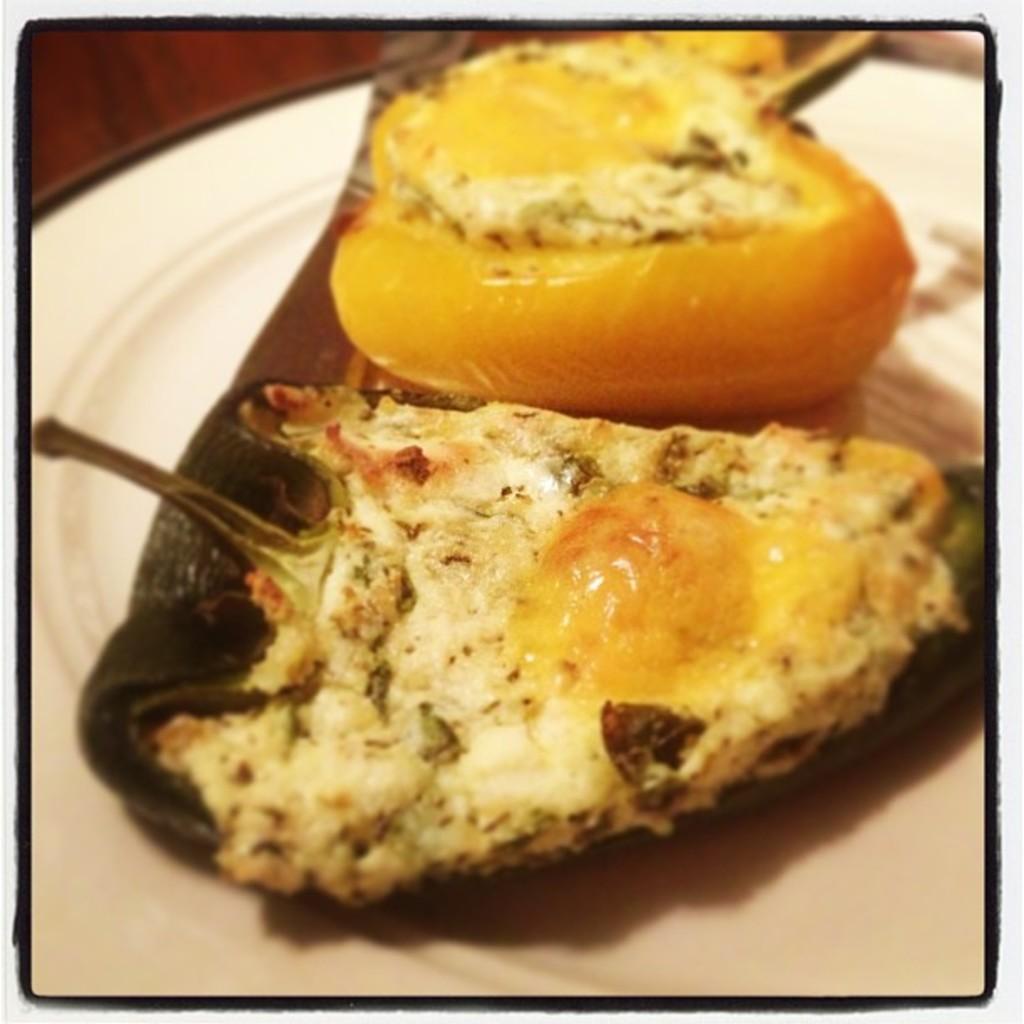Please provide a concise description of this image. In this image I can see a food in a white plate. 